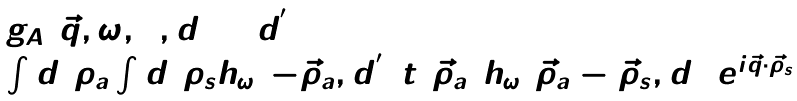Convert formula to latex. <formula><loc_0><loc_0><loc_500><loc_500>\begin{array} { l } g _ { A } ( \vec { q } , \omega , 0 , d _ { 1 } + d ^ { ^ { \prime } } _ { 1 } ) = \\ \int d ^ { 2 } \rho _ { a } \int d ^ { 2 } \rho _ { s } h _ { \omega } ( - \vec { \rho } _ { a } , d ^ { ^ { \prime } } _ { 1 } ) t ( \vec { \rho } _ { a } ) h _ { \omega } ( \vec { \rho } _ { a } - \vec { \rho } _ { s } , d _ { 1 } ) e ^ { i \vec { q } \cdot \vec { \rho } _ { s } } \end{array}</formula> 